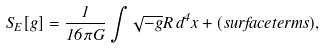Convert formula to latex. <formula><loc_0><loc_0><loc_500><loc_500>S _ { E } [ g ] = \frac { 1 } { 1 6 \pi G } \int { \sqrt { - g } R \, d ^ { 4 } x } + ( s u r f a c e t e r m s ) ,</formula> 